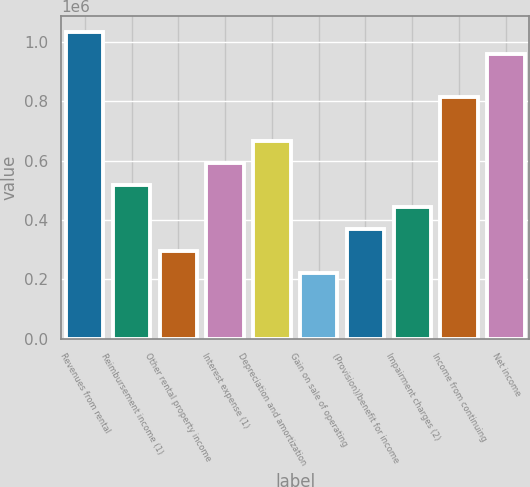Convert chart. <chart><loc_0><loc_0><loc_500><loc_500><bar_chart><fcel>Revenues from rental<fcel>Reimbursement income (1)<fcel>Other rental property income<fcel>Interest expense (1)<fcel>Depreciation and amortization<fcel>Gain on sale of operating<fcel>(Provision)/benefit for income<fcel>Impairment charges (2)<fcel>Income from continuing<fcel>Net income<nl><fcel>1.03588e+06<fcel>517942<fcel>295967<fcel>591934<fcel>665925<fcel>221976<fcel>369959<fcel>443950<fcel>813909<fcel>961892<nl></chart> 